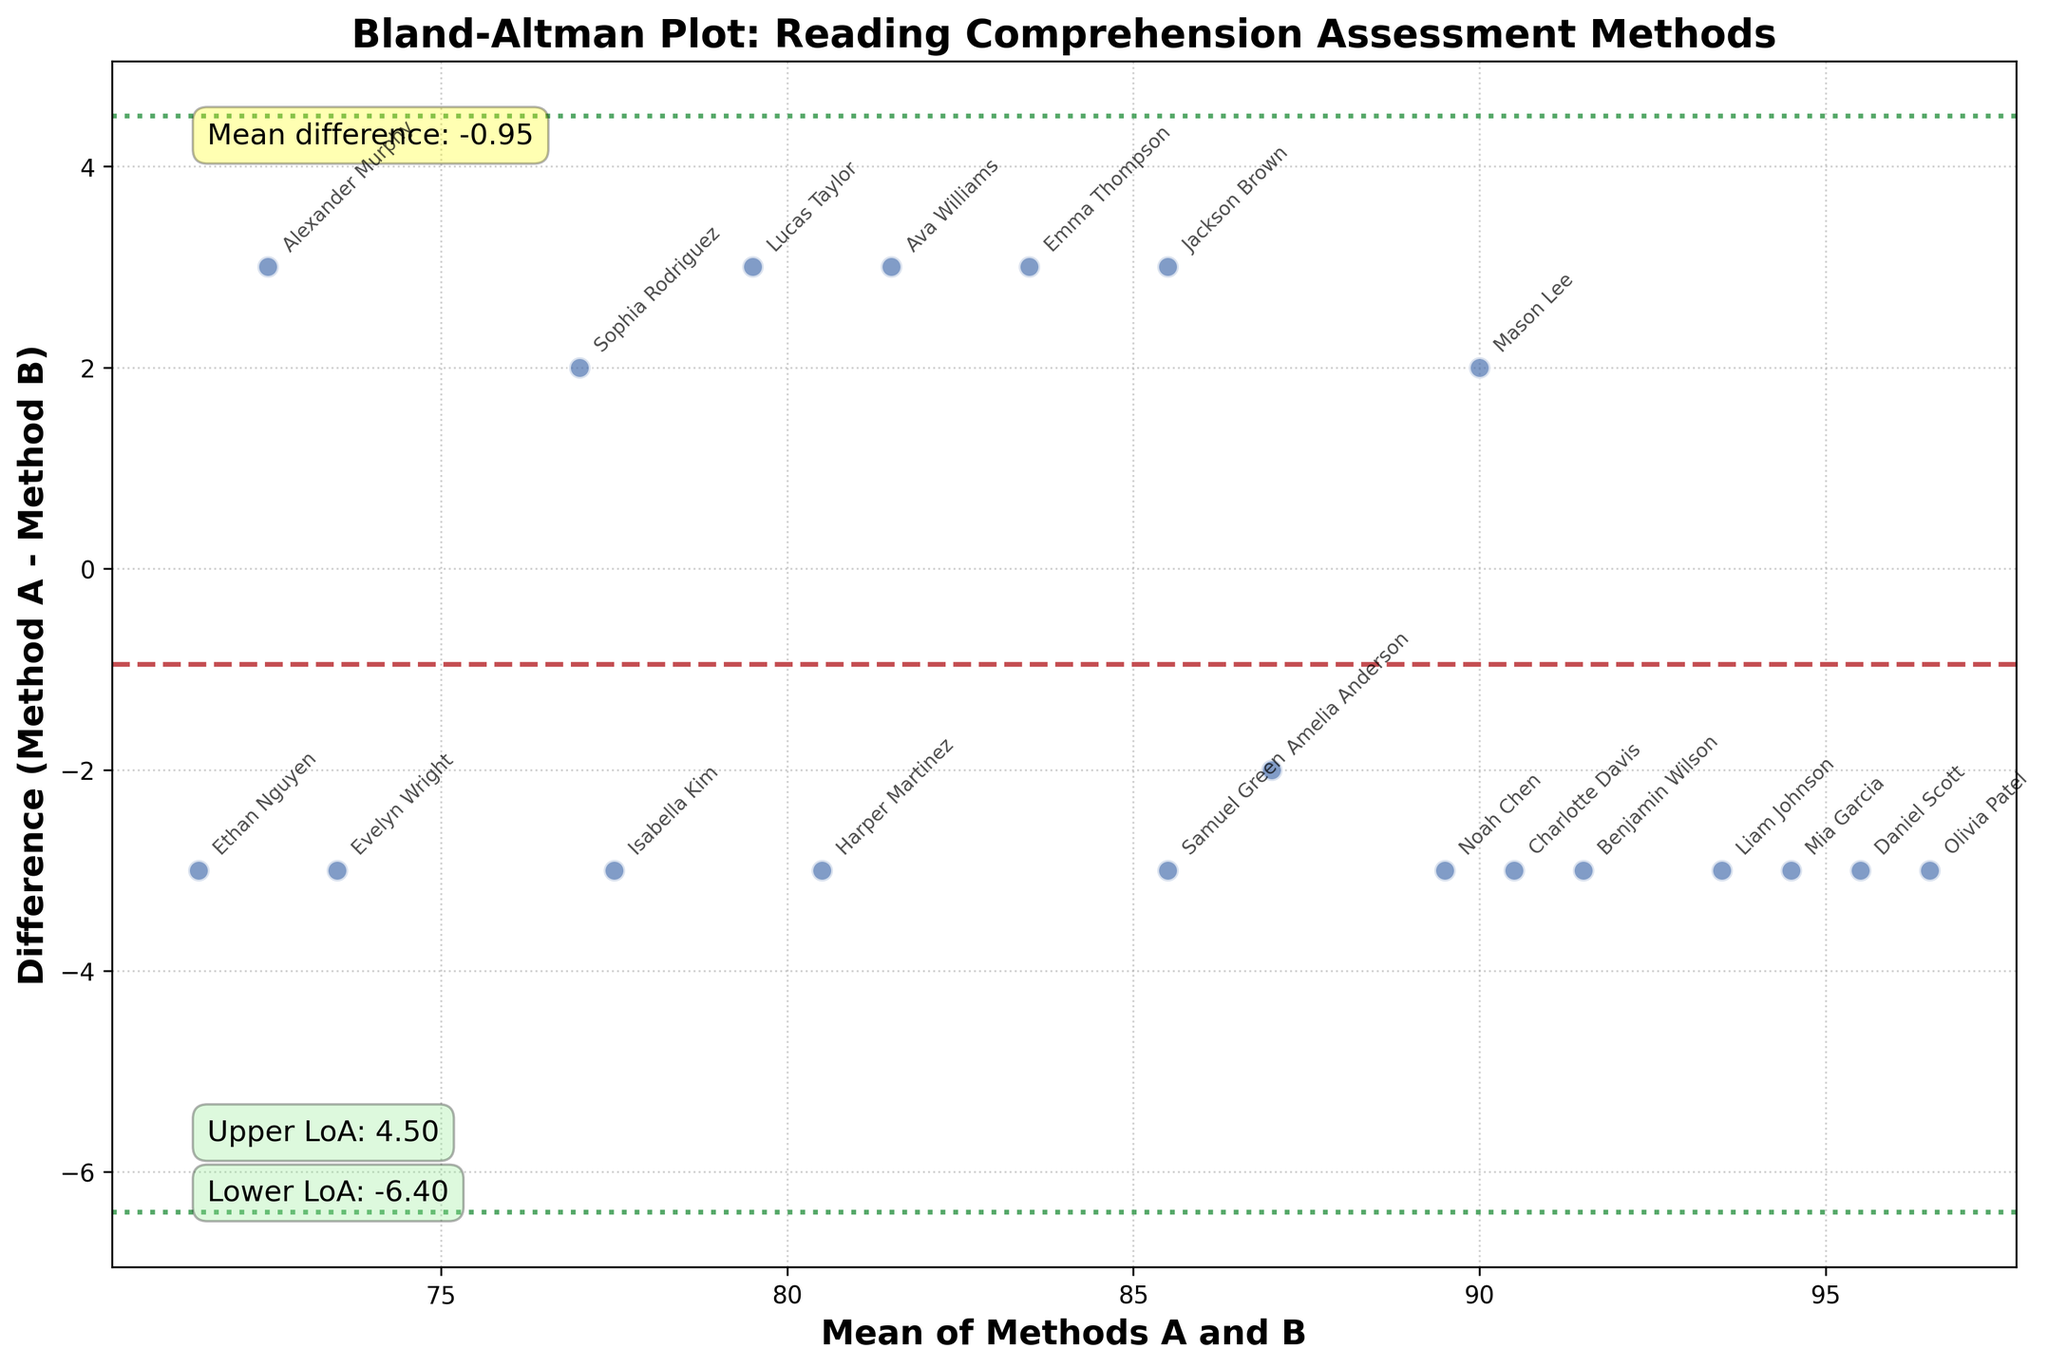What is the title of the plot? The title is typically located at the top of the figure and describes the main purpose or topic of the plot. In this figure, the title directly tells us that it is a Bland-Altman plot related to reading comprehension assessment.
Answer: Bland-Altman Plot: Reading Comprehension Assessment Methods How many data points are plotted in the figure? Each data point represents a student's reading comprehension level difference between Method A and Method B. Count the number of points on the scatter plot. Since each student corresponds to one point, there are 20 students.
Answer: 20 What is the y-axis label? The label of the y-axis describes what the plotted values on the y-axis represent. In this figure, it states the difference between Method A and Method B.
Answer: Difference (Method A - Method B) What does the horizontal dashed line signify? The dashed line typically represents the mean difference between two methods, which is a key component in a Bland-Altman plot for assessing bias.
Answer: Mean difference What do the dotted lines above and below the dashed line represent? The dotted lines represent the limits of agreement, which are calculated as mean difference ± 1.96 times the standard deviation of the differences. They give the range within which most differences between methods lie.
Answer: Limits of agreement For the student Emma Thompson, what's the difference in reading comprehension levels between Method A and Method B? Locate the data point for Emma Thompson based on annotations and read the difference value from the y-axis. The y-value near the annotation "Emma Thompson" gives the difference.
Answer: 3 On average, do Method A and Method B give similar or different results? The mean difference line (horizontal dashed line) provides insight into the systematic bias between the two methods. If it is close to 0, the methods yield similar results on average.
Answer: Similar What is the lower limit of agreement? The lower limit of agreement is indicated by the lower dotted line. According to the plot, it's calculated as mean difference - 1.96 * standard deviation of the differences.
Answer: Approximately -3.10 Which student has the maximum positive difference between Method A and Method B? To find the student with the maximum positive difference, look for the highest data point on the y-axis and read the associated annotation.
Answer: Olivia Patel Do most students' differences between the two methods fall within the limits of agreement? Examine the vertical spread of the data points to see if most fall between the two dotted lines, which represent the limits of agreement.
Answer: Yes 